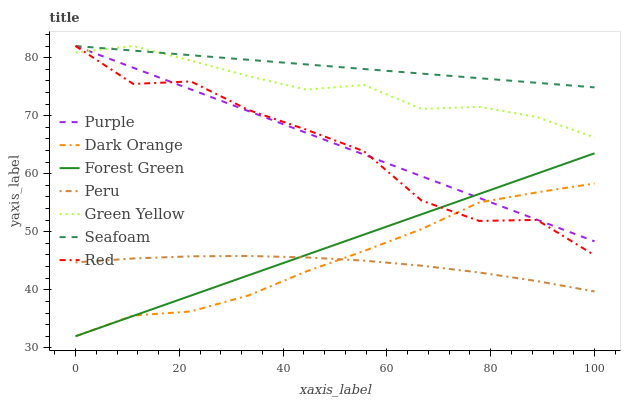Does Peru have the minimum area under the curve?
Answer yes or no. Yes. Does Seafoam have the maximum area under the curve?
Answer yes or no. Yes. Does Purple have the minimum area under the curve?
Answer yes or no. No. Does Purple have the maximum area under the curve?
Answer yes or no. No. Is Purple the smoothest?
Answer yes or no. Yes. Is Red the roughest?
Answer yes or no. Yes. Is Seafoam the smoothest?
Answer yes or no. No. Is Seafoam the roughest?
Answer yes or no. No. Does Dark Orange have the lowest value?
Answer yes or no. Yes. Does Purple have the lowest value?
Answer yes or no. No. Does Red have the highest value?
Answer yes or no. Yes. Does Forest Green have the highest value?
Answer yes or no. No. Is Peru less than Red?
Answer yes or no. Yes. Is Purple greater than Peru?
Answer yes or no. Yes. Does Seafoam intersect Purple?
Answer yes or no. Yes. Is Seafoam less than Purple?
Answer yes or no. No. Is Seafoam greater than Purple?
Answer yes or no. No. Does Peru intersect Red?
Answer yes or no. No. 